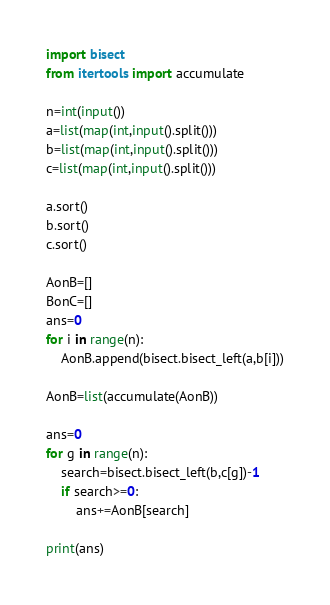Convert code to text. <code><loc_0><loc_0><loc_500><loc_500><_Python_>import bisect
from itertools import accumulate

n=int(input())
a=list(map(int,input().split()))
b=list(map(int,input().split()))
c=list(map(int,input().split()))

a.sort()
b.sort()
c.sort()

AonB=[]
BonC=[]
ans=0
for i in range(n):
    AonB.append(bisect.bisect_left(a,b[i]))

AonB=list(accumulate(AonB))

ans=0
for g in range(n):
    search=bisect.bisect_left(b,c[g])-1
    if search>=0:
        ans+=AonB[search]

print(ans)</code> 